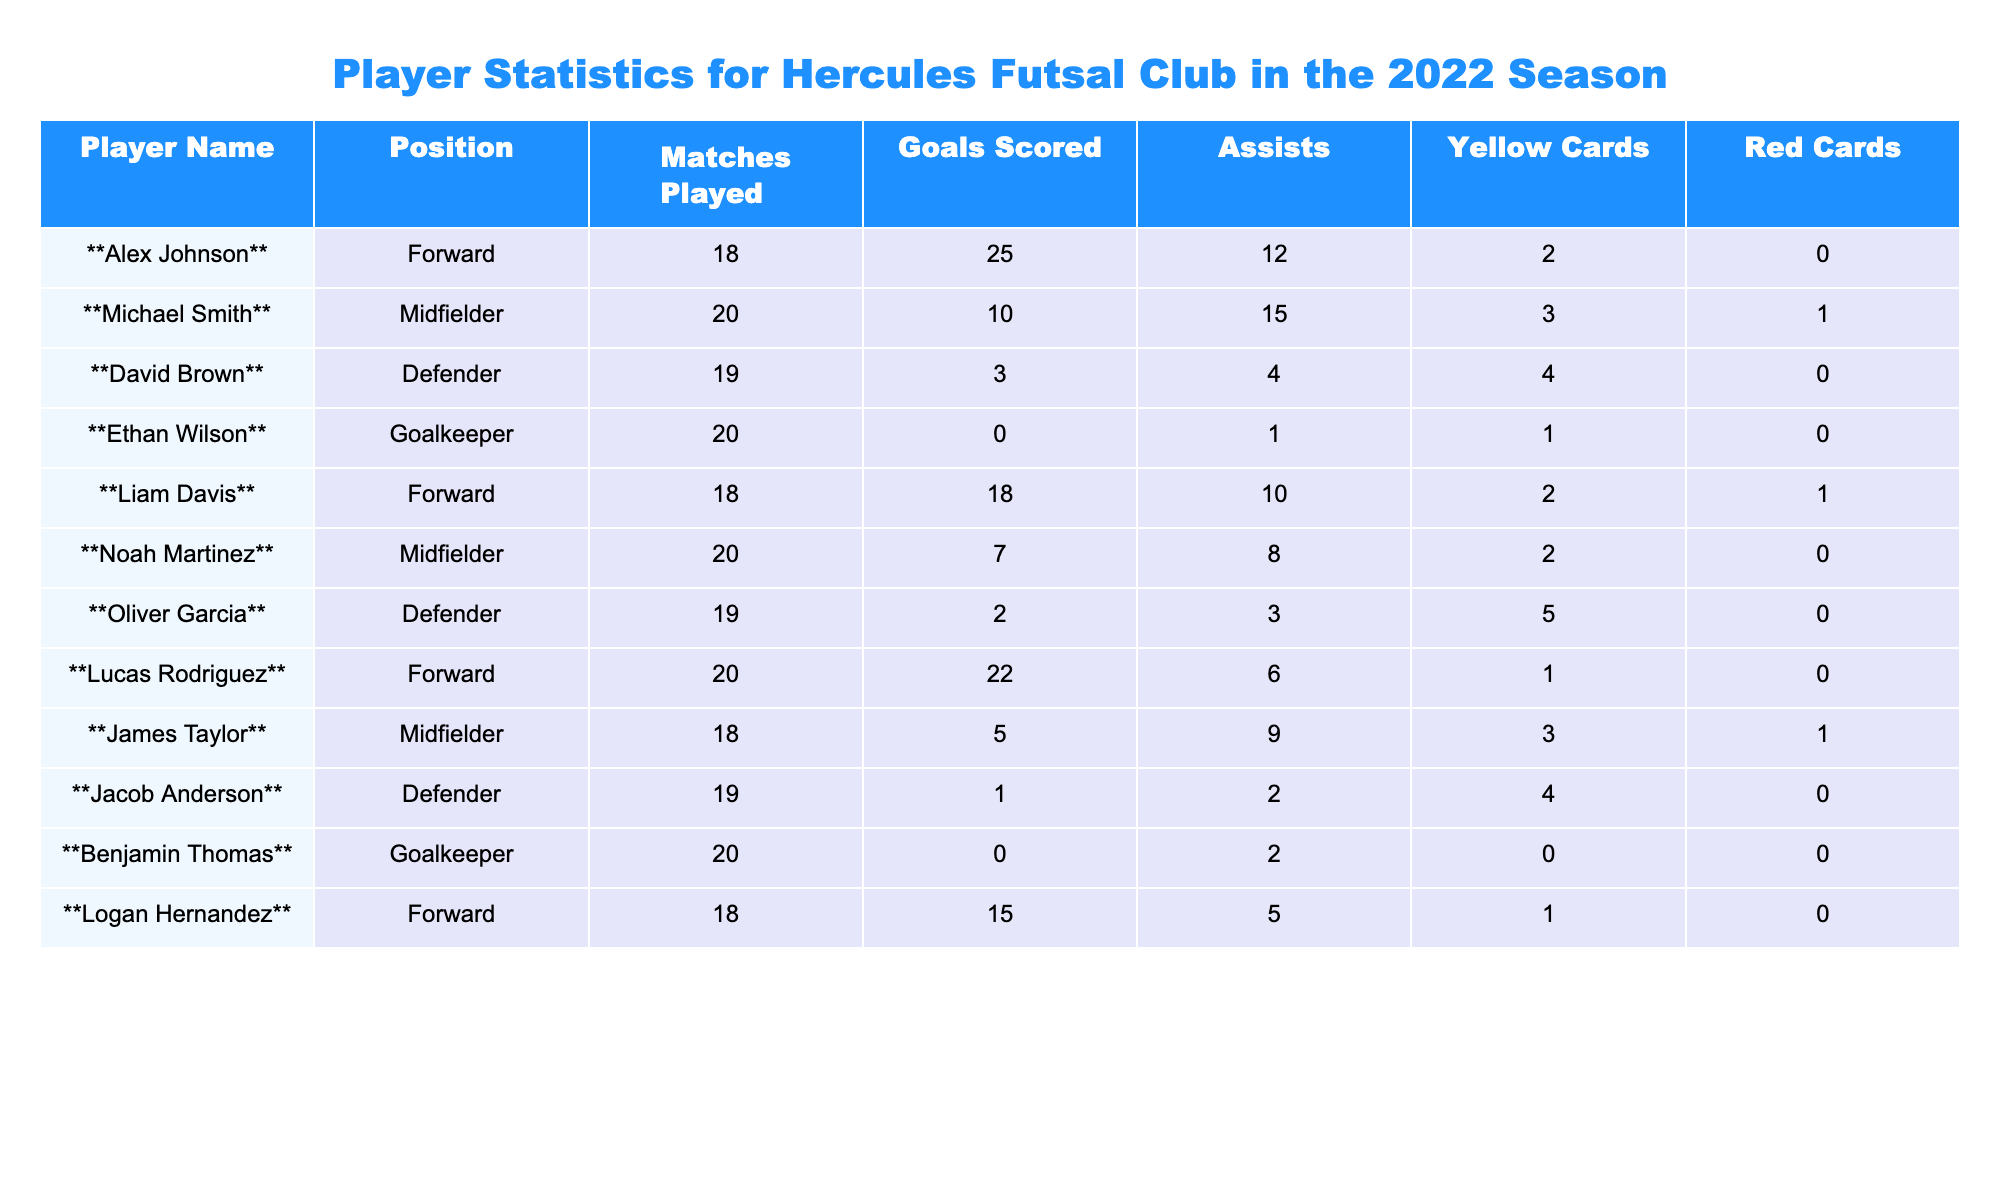What is the total number of goals scored by all players? We can find the total goals by adding each player's goals: (25 + 10 + 3 + 0 + 18 + 7 + 2 + 22 + 5 + 1 + 0 + 15) = 113.
Answer: 113 Which player has the highest number of assists? Looking at the assists column, the player with the highest assists is Alex Johnson with 12 assists.
Answer: Alex Johnson Did any player receive a red card? By checking the red cards column, we see that Michael Smith and Liam Davis received 1 red card each. Therefore, there are players who received red cards.
Answer: Yes What position does Ethan Wilson play? In the position column, it shows that Ethan Wilson plays as a Goalkeeper.
Answer: Goalkeeper How many matches did Liam Davis play? Referring to the matches played column, Liam Davis played 18 matches.
Answer: 18 What is the average number of goals scored by forwards? There are three forwards: Alex Johnson (25), Liam Davis (18), and Lucas Rodriguez (22). The total goals scored by forwards is (25 + 18 + 22) = 65. Since there are 3 forwards, the average is 65/3 = 21.67.
Answer: 21.67 Which defender has the most yellow cards? Reviewing the yellow cards column for defenders, David Brown has 4 yellow cards, which is more than the others: Oliver Garcia (5) and Jacob Anderson (4).
Answer: David Brown Who are the players with zero goals scored? Looking at the goals scored column, we see that Ethan Wilson and Benjamin Thomas both scored 0 goals.
Answer: Ethan Wilson, Benjamin Thomas Which midfielder has the highest assists-to-goals ratio? The midfielders and their ratios are: Michael Smith (1.5), Noah Martinez (1.14), and James Taylor (1.8). The highest ratio is James Taylor with 1.8 assists per goal.
Answer: James Taylor If you combine the matches played by all Goalkeepers, how many matches do they have in total? The matches played by goalkeepers Ethan Wilson (20) and Benjamin Thomas (20) add up to 20 + 20 = 40.
Answer: 40 